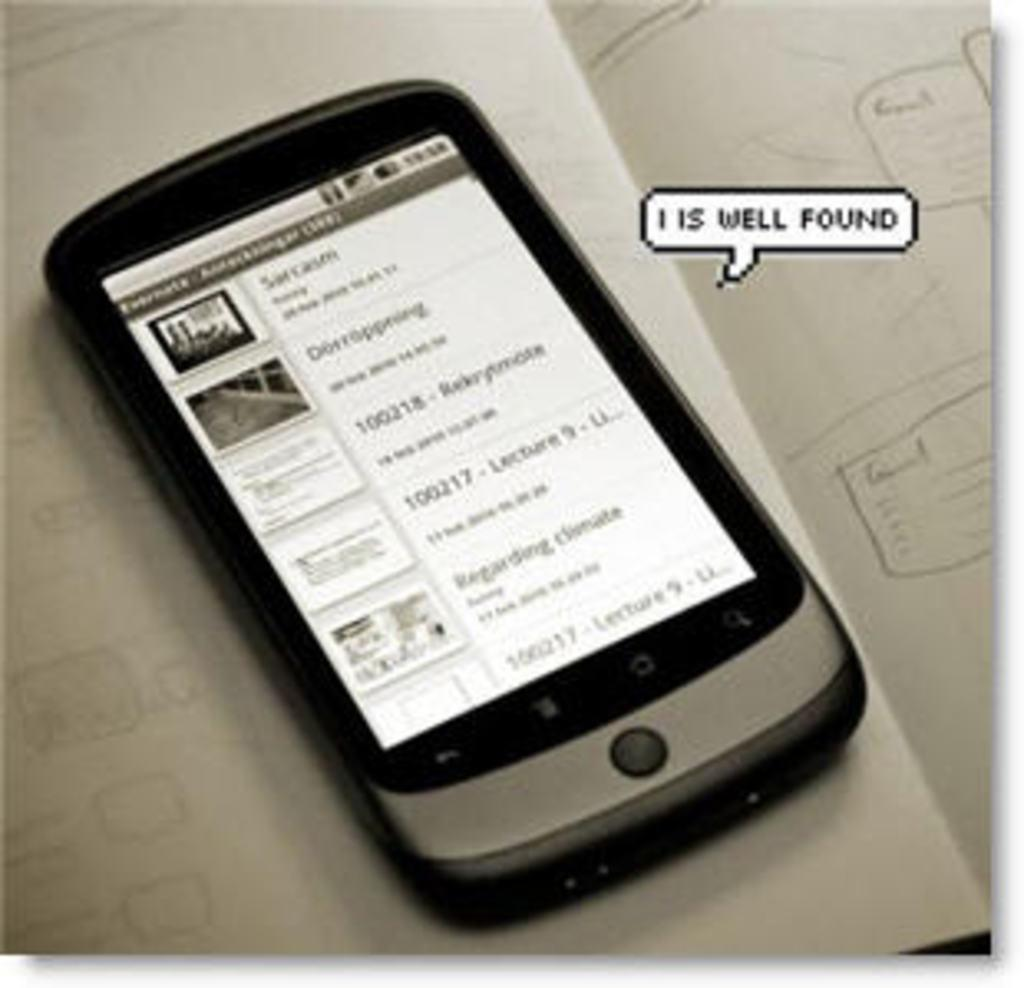What electronic device is present in the image? There is a mobile phone in the image. What can be seen on the mobile phone screen? There is text visible on the mobile phone screen. What is located on the right side of the image? There is text on the right side of the image. What can be seen in the background of the image? There is a book in the background of the image. What type of lettuce is being used as a base for the activity in the image? There is no lettuce or activity present in the image; it features a mobile phone with text on the screen and text on the right side of the image, along with a book in the background. 